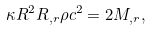Convert formula to latex. <formula><loc_0><loc_0><loc_500><loc_500>\kappa R ^ { 2 } R _ { , r } \rho c ^ { 2 } = 2 M _ { , r } ,</formula> 